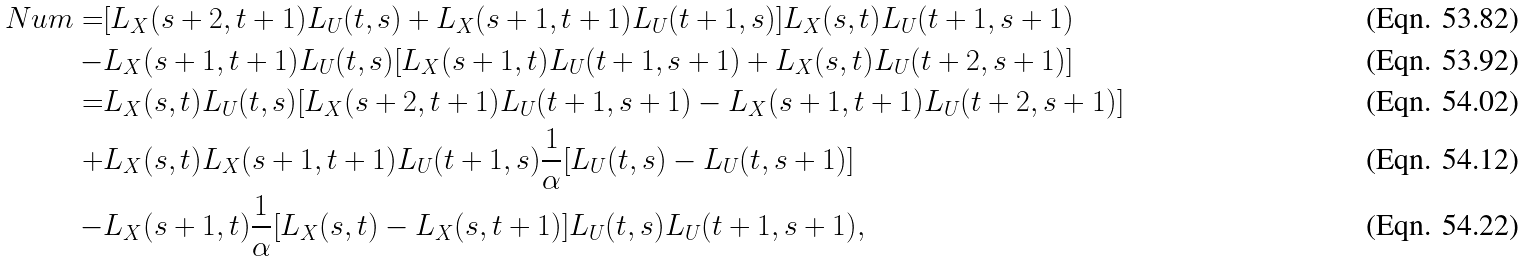Convert formula to latex. <formula><loc_0><loc_0><loc_500><loc_500>N u m = & [ L _ { X } ( s + 2 , t + 1 ) L _ { U } ( t , s ) + L _ { X } ( s + 1 , t + 1 ) L _ { U } ( t + 1 , s ) ] L _ { X } ( s , t ) L _ { U } ( t + 1 , s + 1 ) \\ - & L _ { X } ( s + 1 , t + 1 ) L _ { U } ( t , s ) [ L _ { X } ( s + 1 , t ) L _ { U } ( t + 1 , s + 1 ) + L _ { X } ( s , t ) L _ { U } ( t + 2 , s + 1 ) ] \\ = & L _ { X } ( s , t ) L _ { U } ( t , s ) [ L _ { X } ( s + 2 , t + 1 ) L _ { U } ( t + 1 , s + 1 ) - L _ { X } ( s + 1 , t + 1 ) L _ { U } ( t + 2 , s + 1 ) ] \\ + & L _ { X } ( s , t ) L _ { X } ( s + 1 , t + 1 ) L _ { U } ( t + 1 , s ) \frac { 1 } { \alpha } [ L _ { U } ( t , s ) - L _ { U } ( t , s + 1 ) ] \\ - & L _ { X } ( s + 1 , t ) \frac { 1 } { \alpha } [ L _ { X } ( s , t ) - L _ { X } ( s , t + 1 ) ] L _ { U } ( t , s ) L _ { U } ( t + 1 , s + 1 ) ,</formula> 